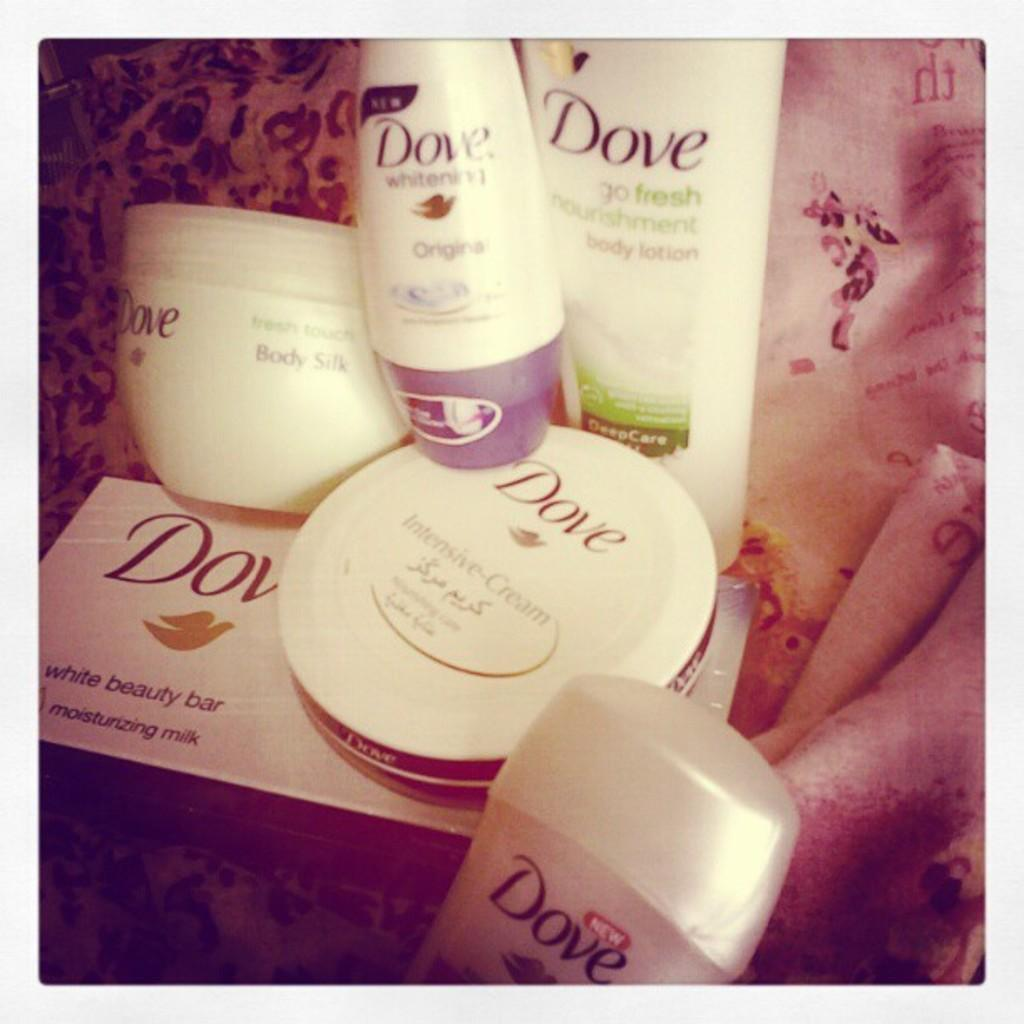<image>
Summarize the visual content of the image. a selection of dove body products, including soap and lotion 